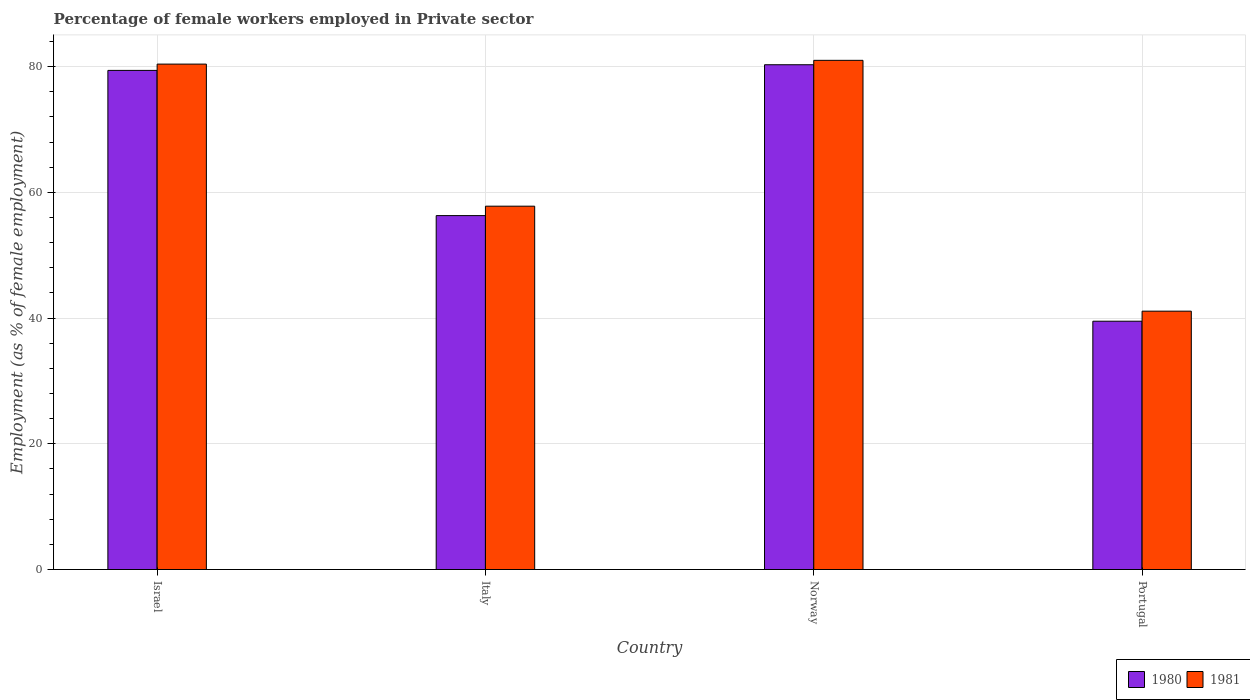Are the number of bars on each tick of the X-axis equal?
Your response must be concise. Yes. How many bars are there on the 3rd tick from the right?
Your answer should be very brief. 2. In how many cases, is the number of bars for a given country not equal to the number of legend labels?
Your response must be concise. 0. What is the percentage of females employed in Private sector in 1981 in Israel?
Give a very brief answer. 80.4. Across all countries, what is the maximum percentage of females employed in Private sector in 1980?
Your response must be concise. 80.3. Across all countries, what is the minimum percentage of females employed in Private sector in 1980?
Keep it short and to the point. 39.5. In which country was the percentage of females employed in Private sector in 1980 minimum?
Offer a very short reply. Portugal. What is the total percentage of females employed in Private sector in 1980 in the graph?
Ensure brevity in your answer.  255.5. What is the difference between the percentage of females employed in Private sector in 1981 in Israel and that in Portugal?
Ensure brevity in your answer.  39.3. What is the difference between the percentage of females employed in Private sector in 1980 in Portugal and the percentage of females employed in Private sector in 1981 in Norway?
Make the answer very short. -41.5. What is the average percentage of females employed in Private sector in 1980 per country?
Provide a short and direct response. 63.88. What is the difference between the percentage of females employed in Private sector of/in 1981 and percentage of females employed in Private sector of/in 1980 in Israel?
Keep it short and to the point. 1. In how many countries, is the percentage of females employed in Private sector in 1981 greater than 24 %?
Give a very brief answer. 4. What is the ratio of the percentage of females employed in Private sector in 1981 in Israel to that in Italy?
Your response must be concise. 1.39. Is the percentage of females employed in Private sector in 1981 in Italy less than that in Norway?
Offer a very short reply. Yes. What is the difference between the highest and the second highest percentage of females employed in Private sector in 1980?
Ensure brevity in your answer.  24. What is the difference between the highest and the lowest percentage of females employed in Private sector in 1980?
Your answer should be very brief. 40.8. What does the 1st bar from the right in Italy represents?
Provide a succinct answer. 1981. How many bars are there?
Provide a succinct answer. 8. Are all the bars in the graph horizontal?
Provide a succinct answer. No. Are the values on the major ticks of Y-axis written in scientific E-notation?
Your answer should be compact. No. Does the graph contain grids?
Offer a very short reply. Yes. How many legend labels are there?
Provide a short and direct response. 2. How are the legend labels stacked?
Offer a very short reply. Horizontal. What is the title of the graph?
Keep it short and to the point. Percentage of female workers employed in Private sector. Does "1996" appear as one of the legend labels in the graph?
Ensure brevity in your answer.  No. What is the label or title of the X-axis?
Offer a terse response. Country. What is the label or title of the Y-axis?
Provide a short and direct response. Employment (as % of female employment). What is the Employment (as % of female employment) of 1980 in Israel?
Keep it short and to the point. 79.4. What is the Employment (as % of female employment) of 1981 in Israel?
Keep it short and to the point. 80.4. What is the Employment (as % of female employment) in 1980 in Italy?
Ensure brevity in your answer.  56.3. What is the Employment (as % of female employment) of 1981 in Italy?
Keep it short and to the point. 57.8. What is the Employment (as % of female employment) in 1980 in Norway?
Offer a very short reply. 80.3. What is the Employment (as % of female employment) of 1981 in Norway?
Keep it short and to the point. 81. What is the Employment (as % of female employment) in 1980 in Portugal?
Provide a succinct answer. 39.5. What is the Employment (as % of female employment) of 1981 in Portugal?
Offer a very short reply. 41.1. Across all countries, what is the maximum Employment (as % of female employment) in 1980?
Your response must be concise. 80.3. Across all countries, what is the minimum Employment (as % of female employment) in 1980?
Offer a terse response. 39.5. Across all countries, what is the minimum Employment (as % of female employment) of 1981?
Your answer should be compact. 41.1. What is the total Employment (as % of female employment) of 1980 in the graph?
Offer a very short reply. 255.5. What is the total Employment (as % of female employment) in 1981 in the graph?
Offer a terse response. 260.3. What is the difference between the Employment (as % of female employment) of 1980 in Israel and that in Italy?
Make the answer very short. 23.1. What is the difference between the Employment (as % of female employment) in 1981 in Israel and that in Italy?
Provide a short and direct response. 22.6. What is the difference between the Employment (as % of female employment) in 1980 in Israel and that in Norway?
Make the answer very short. -0.9. What is the difference between the Employment (as % of female employment) in 1980 in Israel and that in Portugal?
Your response must be concise. 39.9. What is the difference between the Employment (as % of female employment) of 1981 in Israel and that in Portugal?
Your answer should be compact. 39.3. What is the difference between the Employment (as % of female employment) in 1980 in Italy and that in Norway?
Give a very brief answer. -24. What is the difference between the Employment (as % of female employment) of 1981 in Italy and that in Norway?
Your response must be concise. -23.2. What is the difference between the Employment (as % of female employment) in 1981 in Italy and that in Portugal?
Your response must be concise. 16.7. What is the difference between the Employment (as % of female employment) of 1980 in Norway and that in Portugal?
Give a very brief answer. 40.8. What is the difference between the Employment (as % of female employment) of 1981 in Norway and that in Portugal?
Offer a terse response. 39.9. What is the difference between the Employment (as % of female employment) of 1980 in Israel and the Employment (as % of female employment) of 1981 in Italy?
Give a very brief answer. 21.6. What is the difference between the Employment (as % of female employment) of 1980 in Israel and the Employment (as % of female employment) of 1981 in Norway?
Give a very brief answer. -1.6. What is the difference between the Employment (as % of female employment) of 1980 in Israel and the Employment (as % of female employment) of 1981 in Portugal?
Offer a very short reply. 38.3. What is the difference between the Employment (as % of female employment) in 1980 in Italy and the Employment (as % of female employment) in 1981 in Norway?
Your response must be concise. -24.7. What is the difference between the Employment (as % of female employment) of 1980 in Italy and the Employment (as % of female employment) of 1981 in Portugal?
Your answer should be compact. 15.2. What is the difference between the Employment (as % of female employment) of 1980 in Norway and the Employment (as % of female employment) of 1981 in Portugal?
Offer a very short reply. 39.2. What is the average Employment (as % of female employment) of 1980 per country?
Offer a very short reply. 63.88. What is the average Employment (as % of female employment) in 1981 per country?
Keep it short and to the point. 65.08. What is the difference between the Employment (as % of female employment) of 1980 and Employment (as % of female employment) of 1981 in Israel?
Offer a very short reply. -1. What is the difference between the Employment (as % of female employment) in 1980 and Employment (as % of female employment) in 1981 in Portugal?
Keep it short and to the point. -1.6. What is the ratio of the Employment (as % of female employment) in 1980 in Israel to that in Italy?
Offer a terse response. 1.41. What is the ratio of the Employment (as % of female employment) in 1981 in Israel to that in Italy?
Offer a terse response. 1.39. What is the ratio of the Employment (as % of female employment) of 1980 in Israel to that in Norway?
Offer a very short reply. 0.99. What is the ratio of the Employment (as % of female employment) of 1981 in Israel to that in Norway?
Your answer should be compact. 0.99. What is the ratio of the Employment (as % of female employment) in 1980 in Israel to that in Portugal?
Provide a succinct answer. 2.01. What is the ratio of the Employment (as % of female employment) in 1981 in Israel to that in Portugal?
Your response must be concise. 1.96. What is the ratio of the Employment (as % of female employment) in 1980 in Italy to that in Norway?
Make the answer very short. 0.7. What is the ratio of the Employment (as % of female employment) of 1981 in Italy to that in Norway?
Keep it short and to the point. 0.71. What is the ratio of the Employment (as % of female employment) in 1980 in Italy to that in Portugal?
Offer a terse response. 1.43. What is the ratio of the Employment (as % of female employment) in 1981 in Italy to that in Portugal?
Your response must be concise. 1.41. What is the ratio of the Employment (as % of female employment) of 1980 in Norway to that in Portugal?
Make the answer very short. 2.03. What is the ratio of the Employment (as % of female employment) in 1981 in Norway to that in Portugal?
Provide a short and direct response. 1.97. What is the difference between the highest and the second highest Employment (as % of female employment) in 1980?
Make the answer very short. 0.9. What is the difference between the highest and the second highest Employment (as % of female employment) in 1981?
Your answer should be very brief. 0.6. What is the difference between the highest and the lowest Employment (as % of female employment) in 1980?
Provide a short and direct response. 40.8. What is the difference between the highest and the lowest Employment (as % of female employment) of 1981?
Your answer should be compact. 39.9. 